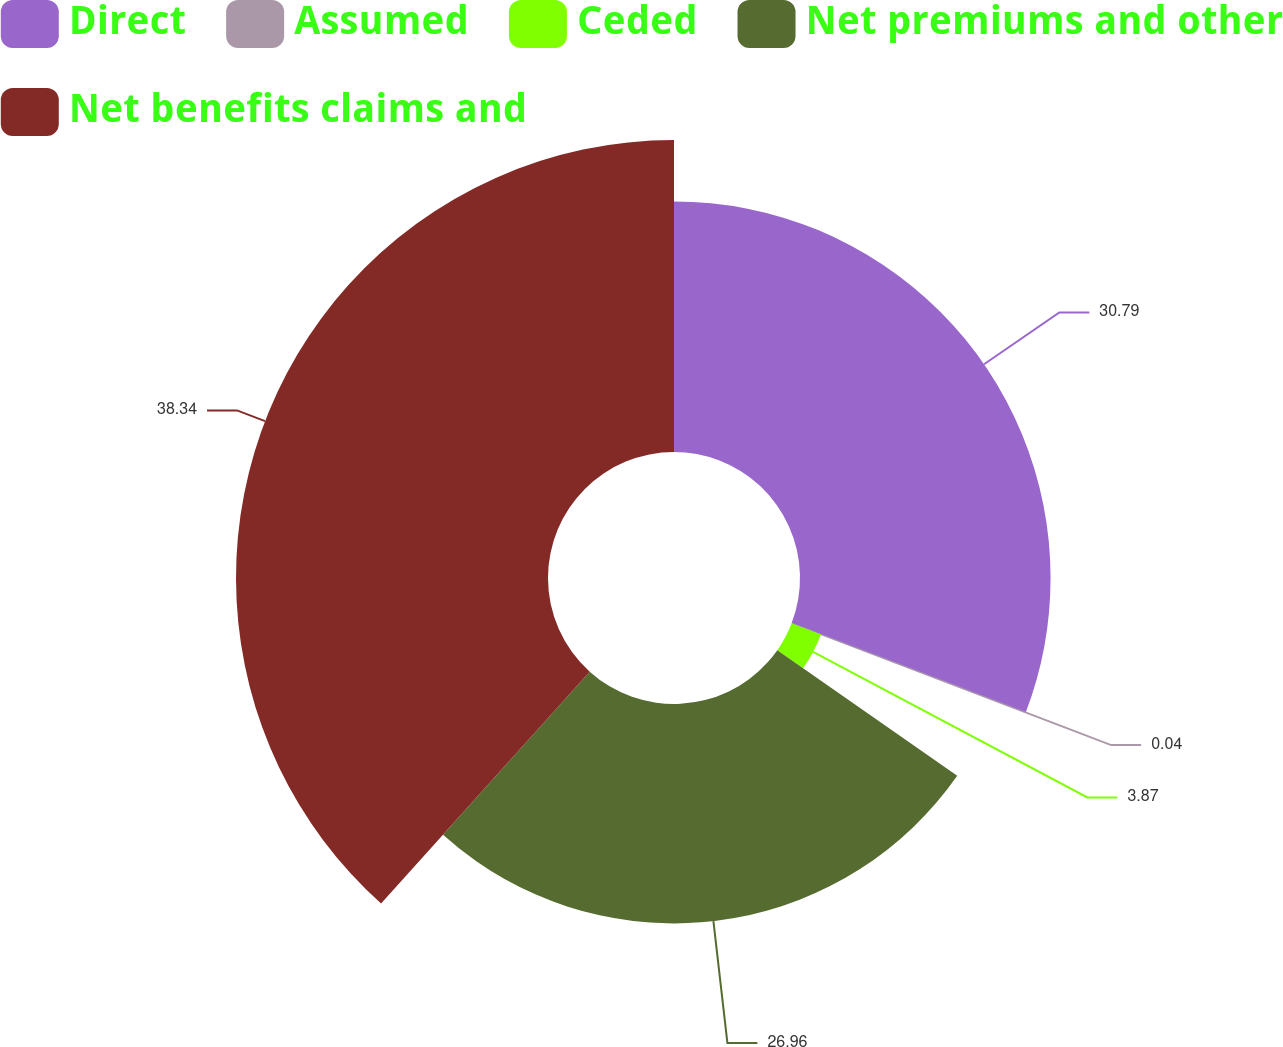Convert chart. <chart><loc_0><loc_0><loc_500><loc_500><pie_chart><fcel>Direct<fcel>Assumed<fcel>Ceded<fcel>Net premiums and other<fcel>Net benefits claims and<nl><fcel>30.79%<fcel>0.04%<fcel>3.87%<fcel>26.96%<fcel>38.34%<nl></chart> 